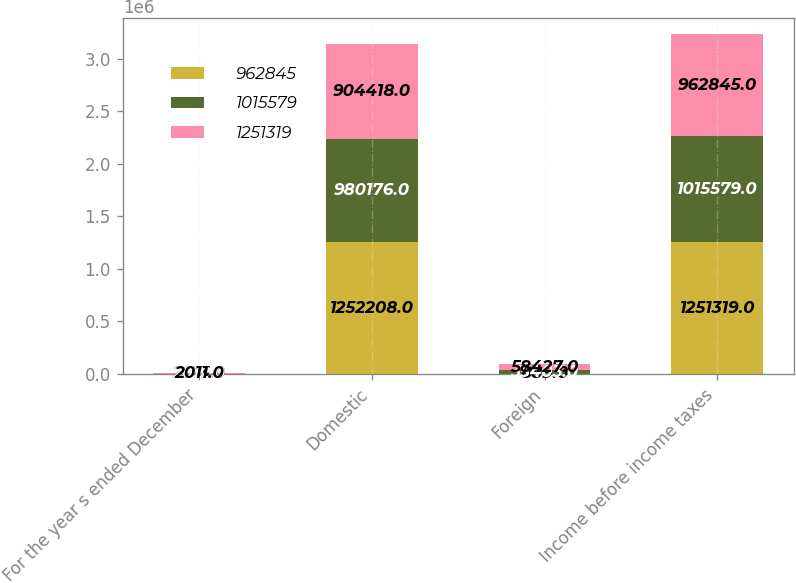Convert chart. <chart><loc_0><loc_0><loc_500><loc_500><stacked_bar_chart><ecel><fcel>For the year s ended December<fcel>Domestic<fcel>Foreign<fcel>Income before income taxes<nl><fcel>962845<fcel>2013<fcel>1.25221e+06<fcel>889<fcel>1.25132e+06<nl><fcel>1.01558e+06<fcel>2012<fcel>980176<fcel>35403<fcel>1.01558e+06<nl><fcel>1.25132e+06<fcel>2011<fcel>904418<fcel>58427<fcel>962845<nl></chart> 